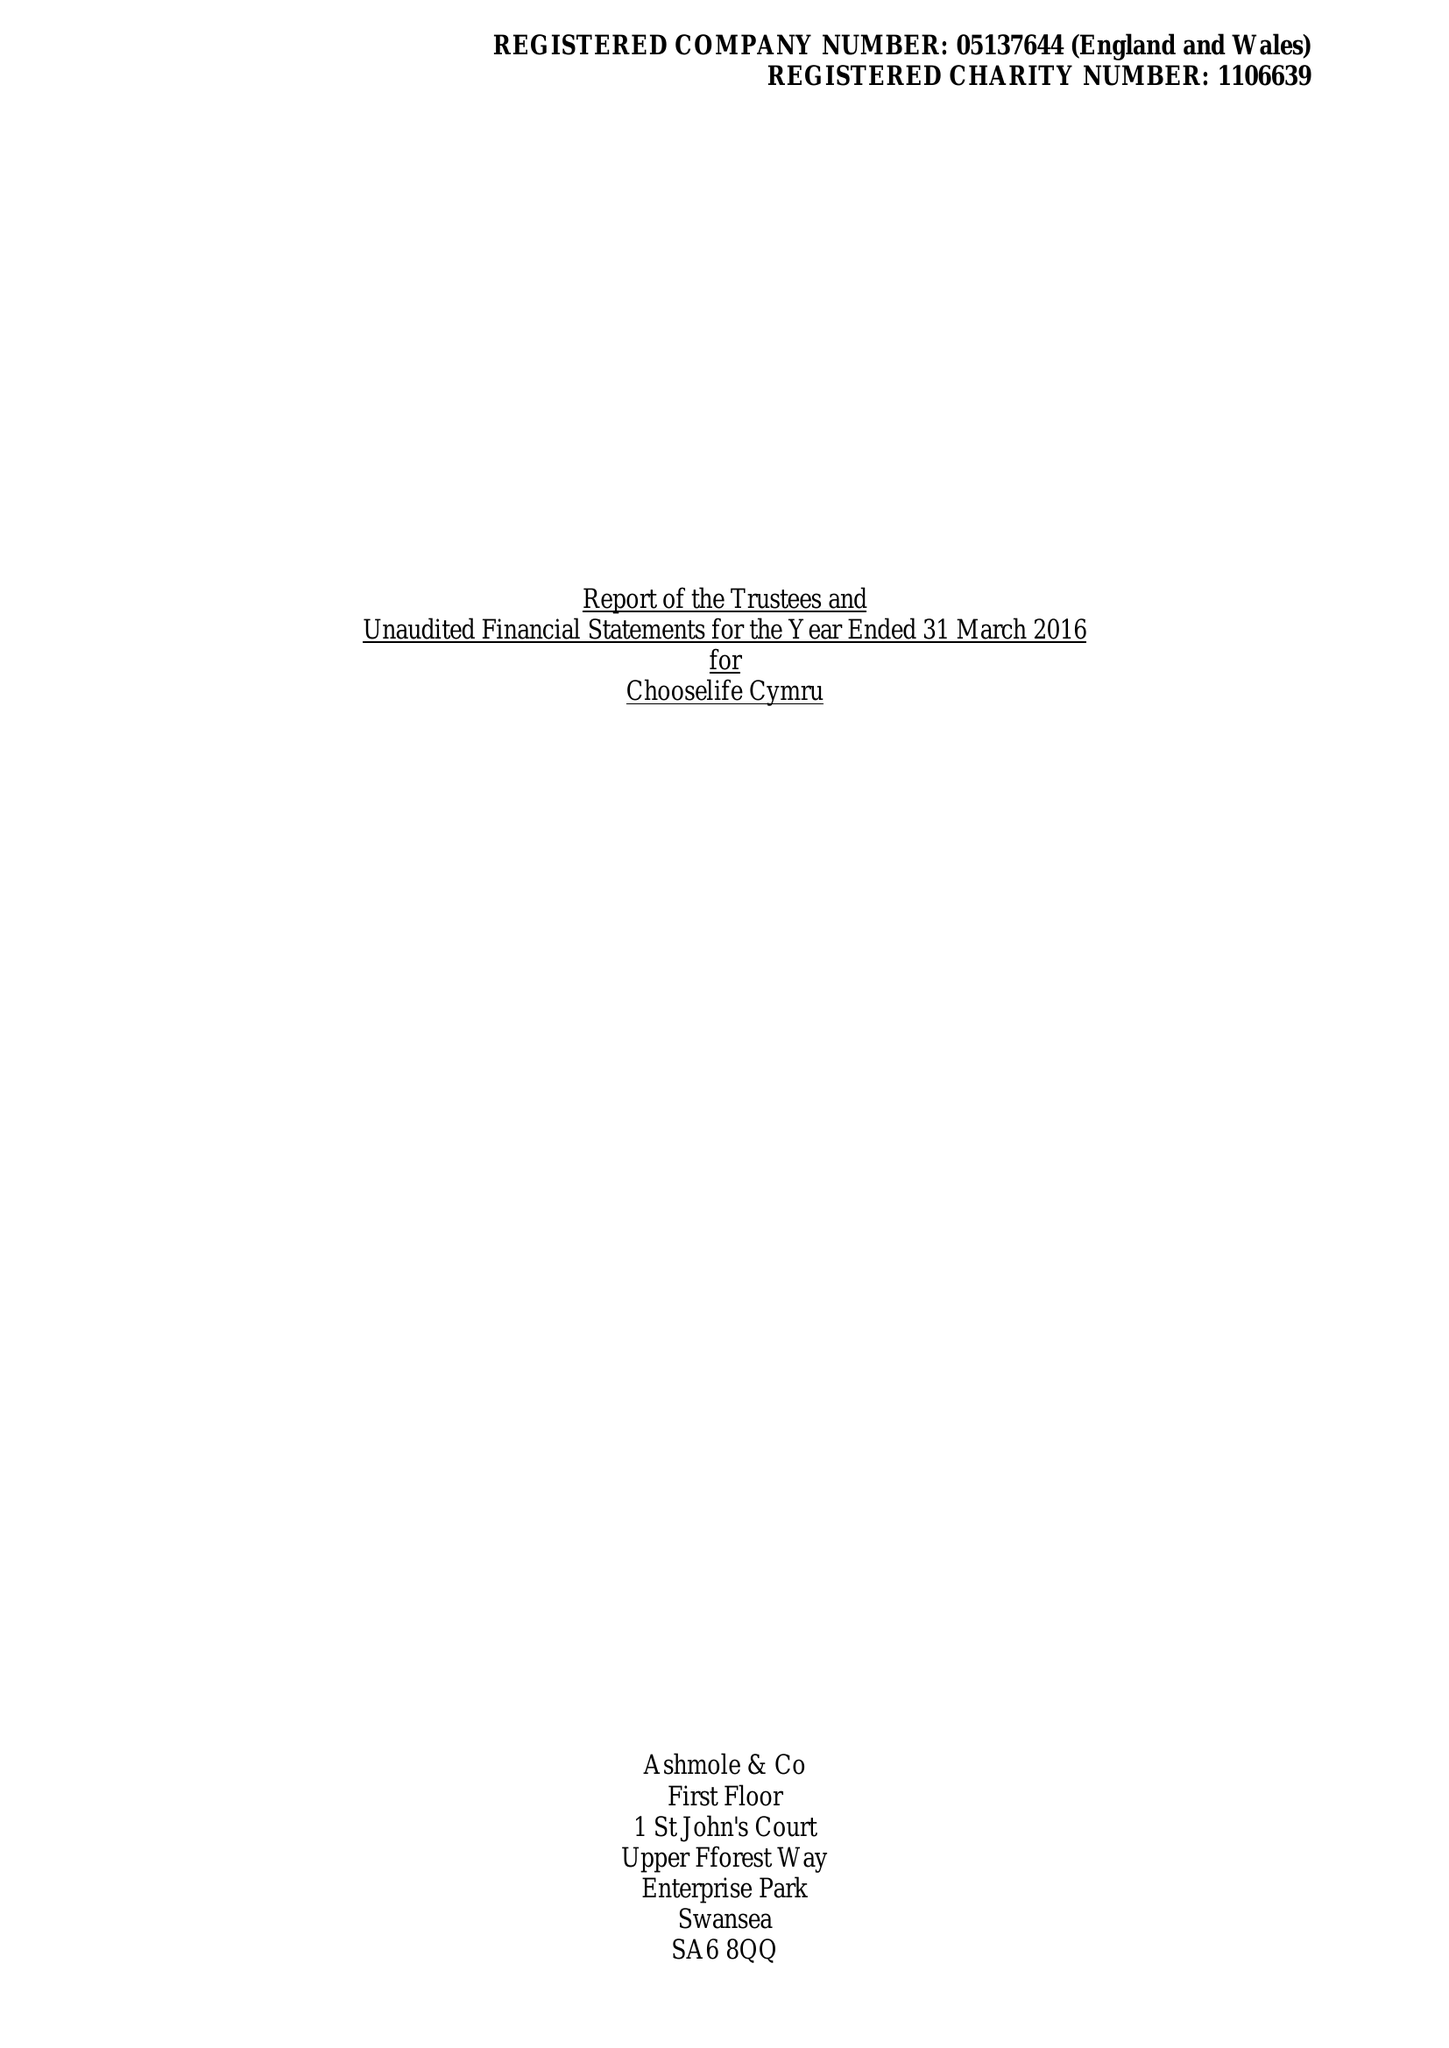What is the value for the charity_name?
Answer the question using a single word or phrase. Chooselife Cymru 